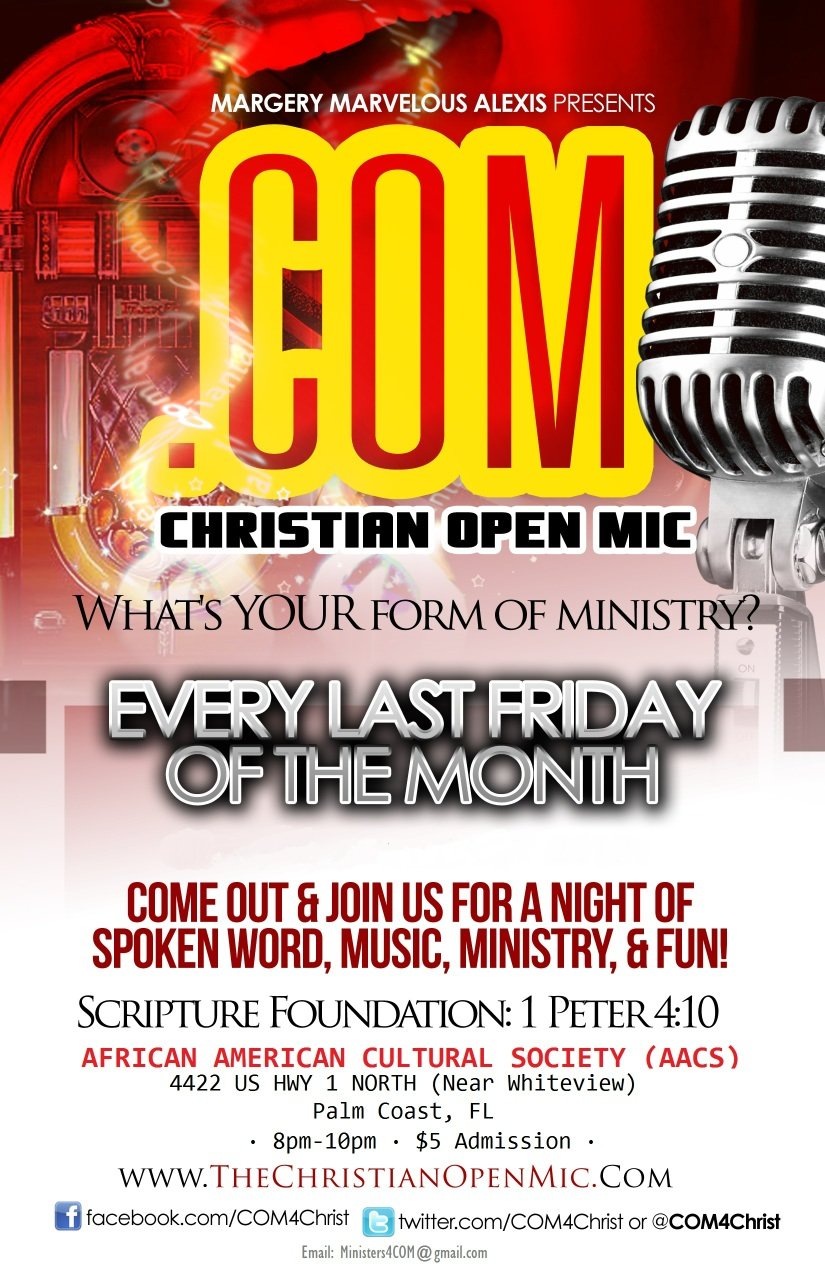Can you tell me more about the venue where the Christian Open Mic is held? The venue for the Christian Open Mic is the African American Cultural Society located at 4422 US HWY 1 North, near Whiteview in Palm Coast, FL. This location is known for hosting cultural events and activities that celebrate and promote African American heritage and community engagement. 